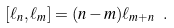Convert formula to latex. <formula><loc_0><loc_0><loc_500><loc_500>[ \ell _ { n } , \ell _ { m } ] = ( n - m ) \ell _ { m + n } \ .</formula> 